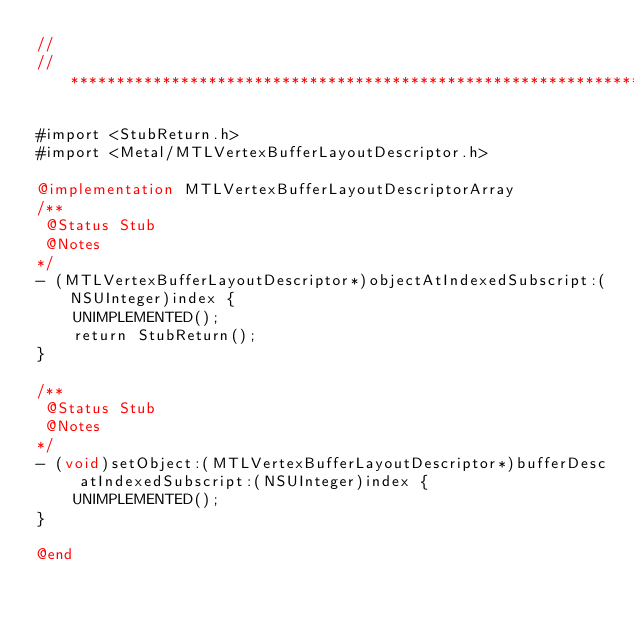<code> <loc_0><loc_0><loc_500><loc_500><_ObjectiveC_>//
//******************************************************************************

#import <StubReturn.h>
#import <Metal/MTLVertexBufferLayoutDescriptor.h>

@implementation MTLVertexBufferLayoutDescriptorArray
/**
 @Status Stub
 @Notes
*/
- (MTLVertexBufferLayoutDescriptor*)objectAtIndexedSubscript:(NSUInteger)index {
    UNIMPLEMENTED();
    return StubReturn();
}

/**
 @Status Stub
 @Notes
*/
- (void)setObject:(MTLVertexBufferLayoutDescriptor*)bufferDesc atIndexedSubscript:(NSUInteger)index {
    UNIMPLEMENTED();
}

@end
</code> 